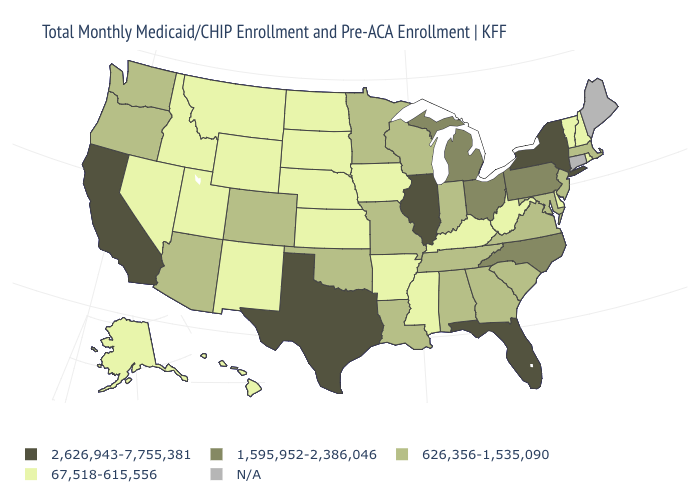Among the states that border New York , does Vermont have the lowest value?
Be succinct. Yes. What is the highest value in states that border Kentucky?
Be succinct. 2,626,943-7,755,381. Which states have the highest value in the USA?
Answer briefly. California, Florida, Illinois, New York, Texas. How many symbols are there in the legend?
Quick response, please. 5. What is the lowest value in the USA?
Concise answer only. 67,518-615,556. Does Kentucky have the lowest value in the South?
Write a very short answer. Yes. Name the states that have a value in the range 2,626,943-7,755,381?
Give a very brief answer. California, Florida, Illinois, New York, Texas. Among the states that border Maryland , does Delaware have the lowest value?
Write a very short answer. Yes. Does Rhode Island have the lowest value in the Northeast?
Concise answer only. Yes. What is the value of Kentucky?
Short answer required. 67,518-615,556. What is the value of Louisiana?
Concise answer only. 626,356-1,535,090. Which states have the lowest value in the West?
Give a very brief answer. Alaska, Hawaii, Idaho, Montana, Nevada, New Mexico, Utah, Wyoming. What is the highest value in the Northeast ?
Write a very short answer. 2,626,943-7,755,381. Which states have the lowest value in the USA?
Quick response, please. Alaska, Arkansas, Delaware, Hawaii, Idaho, Iowa, Kansas, Kentucky, Mississippi, Montana, Nebraska, Nevada, New Hampshire, New Mexico, North Dakota, Rhode Island, South Dakota, Utah, Vermont, West Virginia, Wyoming. What is the value of Oregon?
Be succinct. 626,356-1,535,090. 